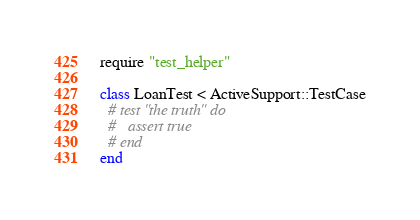Convert code to text. <code><loc_0><loc_0><loc_500><loc_500><_Ruby_>require "test_helper"

class LoanTest < ActiveSupport::TestCase
  # test "the truth" do
  #   assert true
  # end
end
</code> 